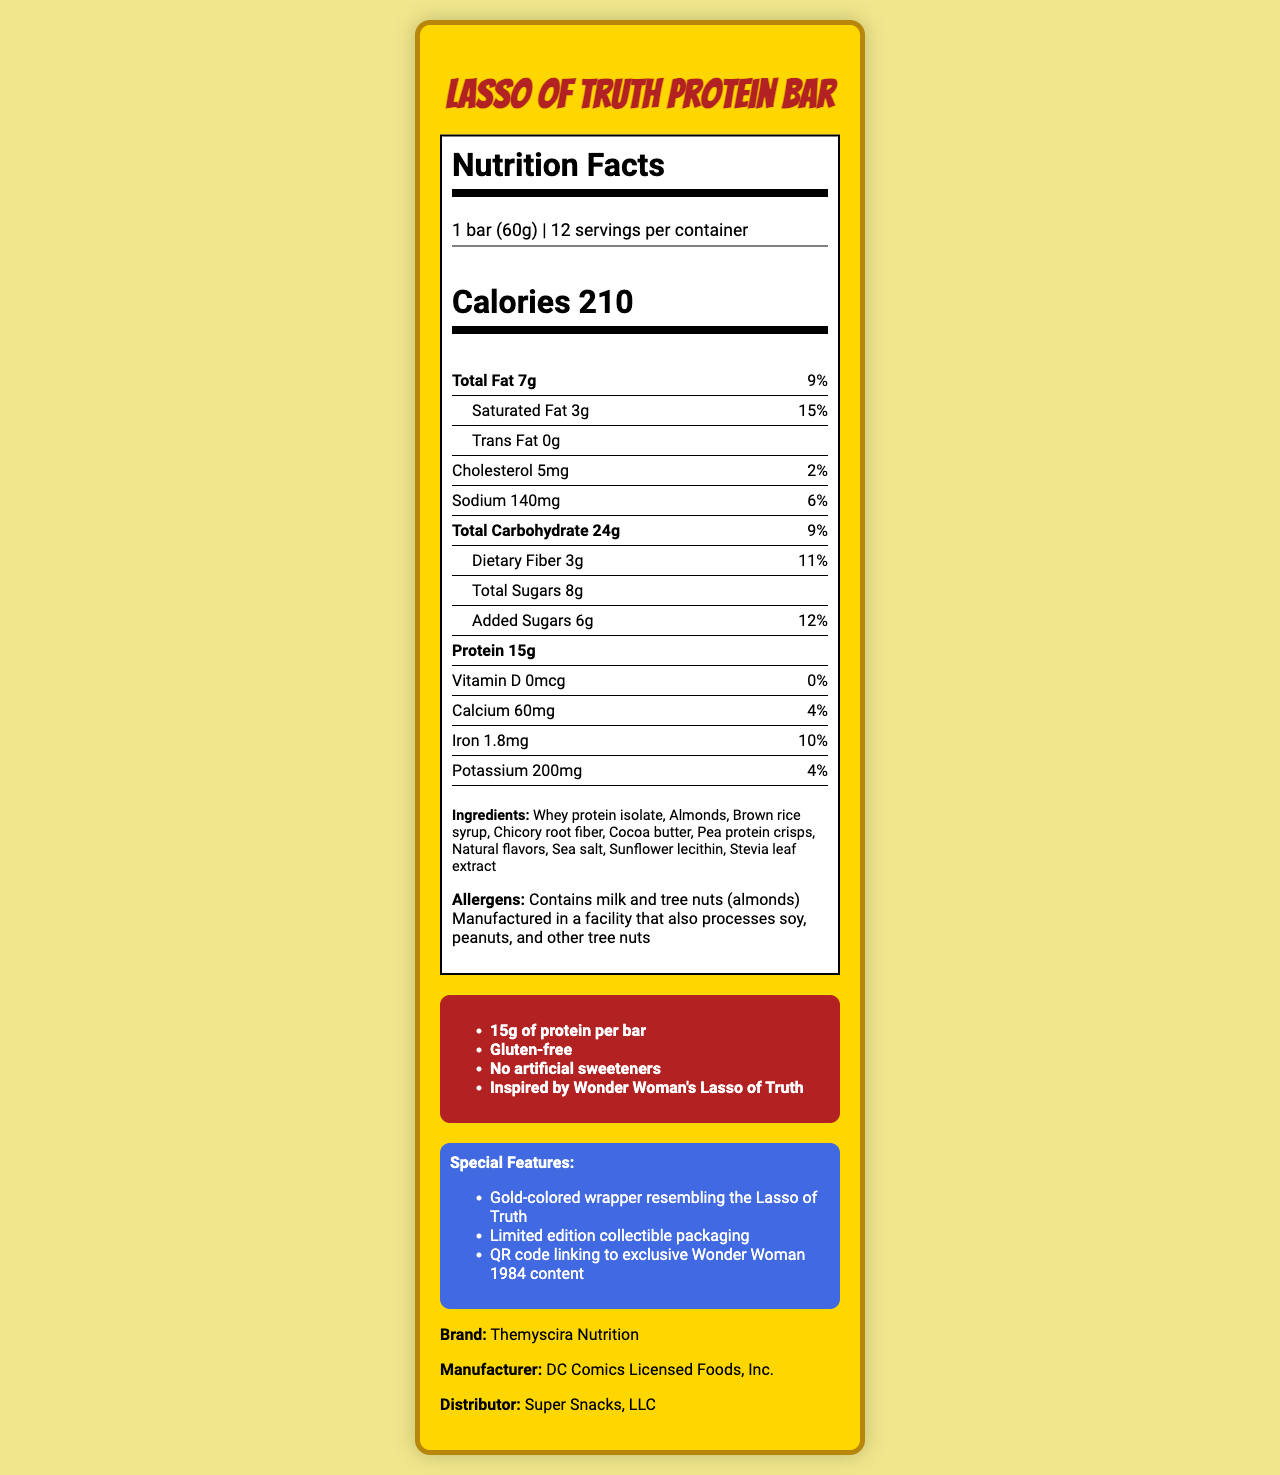what is the serving size? The serving size is displayed as "1 bar (60g)" in the document.
Answer: 1 bar (60g) how many calories are in one serving of the Lasso of Truth Protein Bar? The document lists the calories per serving as 210.
Answer: 210 calories what is the amount of total fat in the Lasso of Truth Protein Bar? The total fat content is shown as 7g.
Answer: 7g how many grams of protein does one bar contain? The protein content per bar is listed as 15g.
Answer: 15g what allergens does the Lasso of Truth Protein Bar contain? The allergens are listed as containing milk and tree nuts (almonds).
Answer: Milk and tree nuts (almonds) what is the percentage daily value of saturated fat per serving? The document shows the saturated fat daily value as 15%.
Answer: 15% how many servings are in one container? The document states there are 12 servings per container.
Answer: 12 what marketing claims are made about the Lasso of Truth Protein Bar? The document lists these as the marketing claims.
Answer: 15g of protein per bar, Gluten-free, No artificial sweeteners, Inspired by Wonder Woman's Lasso of Truth how many grams of dietary fiber are in one serving? The dietary fiber content per serving is 3g.
Answer: 3g how much sodium is in one serving of the protein bar? The document lists sodium content per serving as 140mg.
Answer: 140mg which of the following is NOT an ingredient in the Lasso of Truth Protein Bar? (A) Whey protein isolate (B) Almonds (C) High fructose corn syrup (D) Cocoa butter High fructose corn syrup is not listed as an ingredient.
Answer: C which marketing claim is featured on the Lasso of Truth Protein Bar? (i) 10g of protein (ii) Low sodium (iii) Gluten-free (iv) Non-GMO The Lasso of Truth Protein Bar claims it is "Gluten-free."
Answer: iii is the Lasso of Truth Protein Bar gluten-free? The marketing claims include "Gluten-free."
Answer: Yes describe the main idea of the document. The document includes nutritional details such as serving size, calorie content, and various nutrients, as well as ingredient lists, allergen information, marketing claims, and special features like the collectible packaging and QR code.
Answer: The document provides detailed nutrition facts, ingredients, allergens, marketing claims, and special features of the Lasso of Truth Protein Bar, inspired by Wonder Woman 1984. who manufactures the Lasso of Truth Protein Bar? The manufacturer is listed as DC Comics Licensed Foods, Inc.
Answer: DC Comics Licensed Foods, Inc. are there any artificial sweeteners in the Lasso of Truth Protein Bar? The marketing claims specify that there are no artificial sweeteners.
Answer: No what color is the packaging of the Lasso of Truth Protein Bar? The document does not provide information about the color of the packaging.
Answer: Cannot be determined based on the document, what special content is accessible through the QR code on the packaging? The special features mention a QR code linking to exclusive Wonder Woman 1984 content.
Answer: Exclusive Wonder Woman 1984 content 